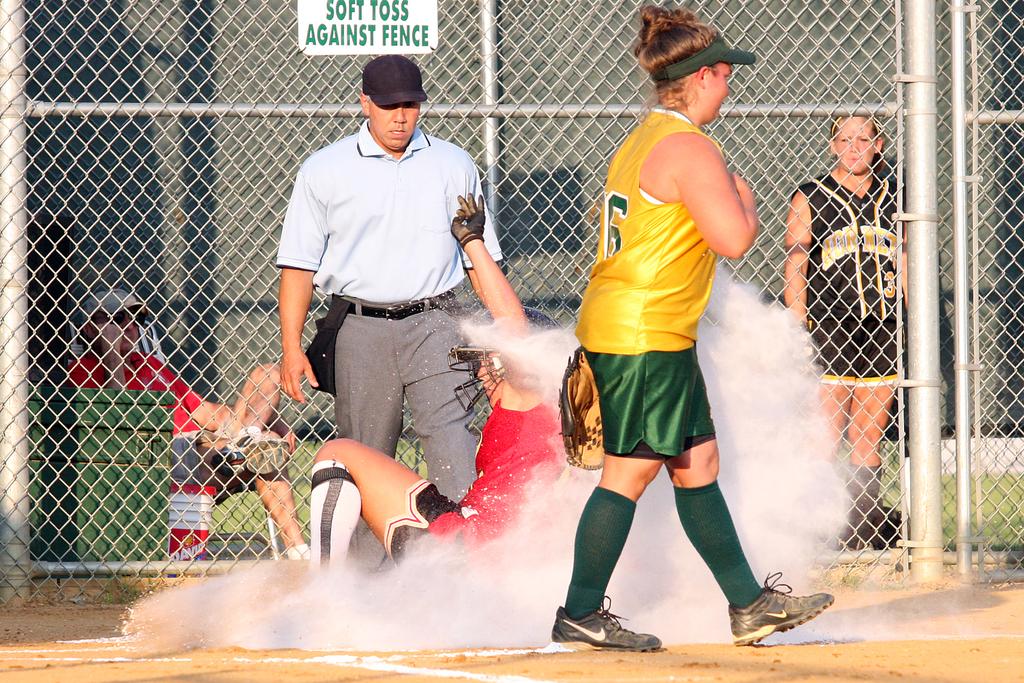How do they want you to toss against the fence?
Give a very brief answer. Soft toss. Does that say soft toss against the fence on the top of the fence?
Offer a terse response. Yes. 